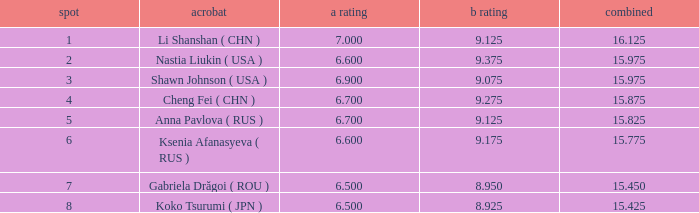What the B Score when the total is 16.125 and the position is less than 7? 9.125. 